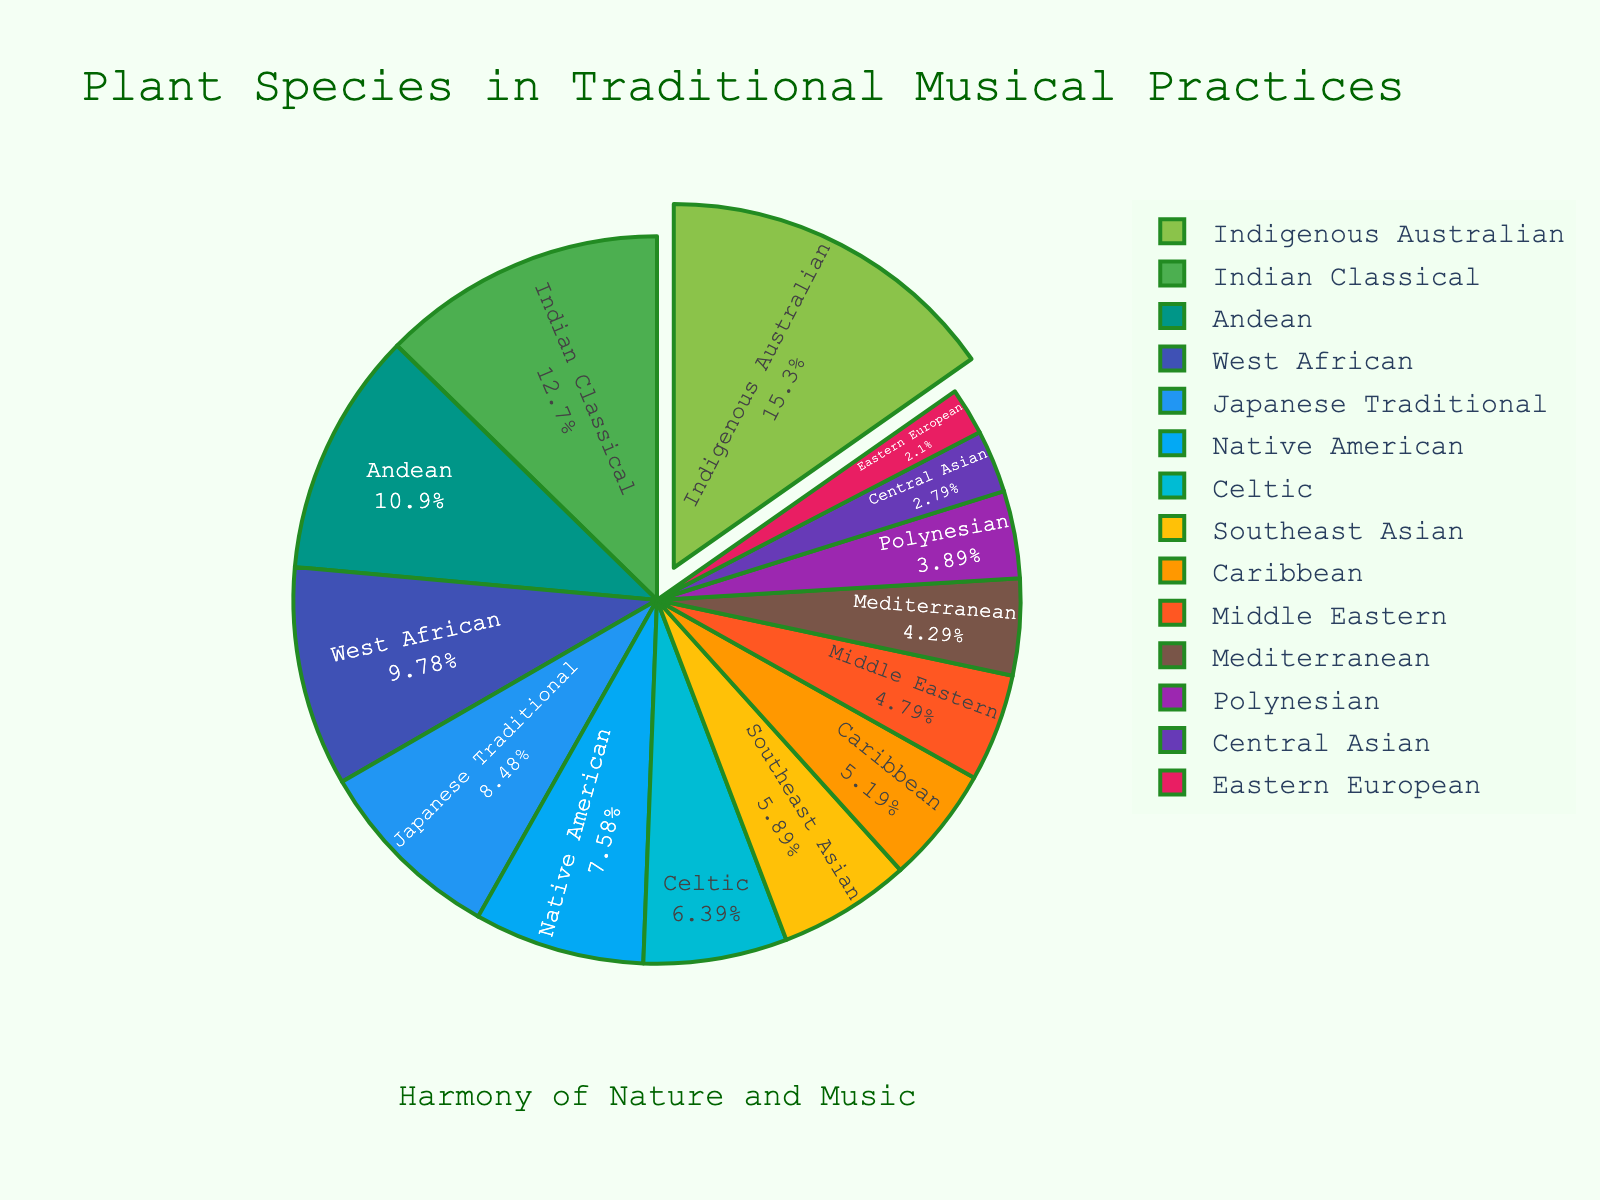What's the highest percentage of plant species used across cultures? To determine this, look for the slice with the largest percentage label on the pie chart. The 'Indigenous Australian' culture has the largest slice.
Answer: 15.3% Which cultures have a percentage less than or equal to 5%? Identify all slices with a percentage label of 5% or less. The cultures in question are Caribbean, Middle Eastern, Mediterranean, Polynesian, Central Asian, and Eastern European.
Answer: Caribbean, Middle Eastern, Mediterranean, Polynesian, Central Asian, Eastern European How much greater is the percentage of plant species used in Indigenous Australian practices compared to Japanese Traditional practices? Subtract the percentage of Japanese Traditional (8.5%) from Indigenous Australian (15.3%) to find the difference. 15.3% - 8.5% = 6.8%.
Answer: 6.8% What is the total percentage of plant species used in West African and Indian Classical musical practices combined? Add the percentages for West African (9.8%) and Indian Classical (12.7%). 9.8% + 12.7% = 22.5%.
Answer: 22.5% Of the Native American, Celtic, and Southeast Asian cultures, which one uses the highest percentage of plant species? Compare the percentages of Native American (7.6%), Celtic (6.4%), and Southeast Asian (5.9%) cultures. Native American has the highest percentage.
Answer: Native American What is the average percentage of plant species used among Andean, Polynesian, and Central Asian practices? Add the percentages for Andean (10.9%), Polynesian (3.9%), and Central Asian (2.8%), then divide by 3. (10.9% + 3.9% + 2.8%) / 3 ≈ 5.87%.
Answer: 5.87% How does the percentage of plant species used in Native American practices compare to Caribbean practices? Compare the percentages of Native American (7.6%) and Caribbean (5.2%). Native American is greater.
Answer: Native American is greater Which culture's slice is visually represented with a pull effect (slightly separated from the pie)? Identify the slice that is slightly pulled out from the pie. The 'Indigenous Australian' slice is the one with the pull effect.
Answer: Indigenous Australian What is the percentage difference between Indian Classical and Eastern European musical practices? Subtract the percentage of Eastern European (2.1%) from Indian Classical (12.7%) to find the difference. 12.7% - 2.1% = 10.6%.
Answer: 10.6% What is the combined percentage of plant species used in Southeast Asian, Caribbean, and Mediterranean musical practices? Add the percentages for Southeast Asian (5.9%), Caribbean (5.2%), and Mediterranean (4.3%). 5.9% + 5.2% + 4.3% = 15.4%.
Answer: 15.4% 